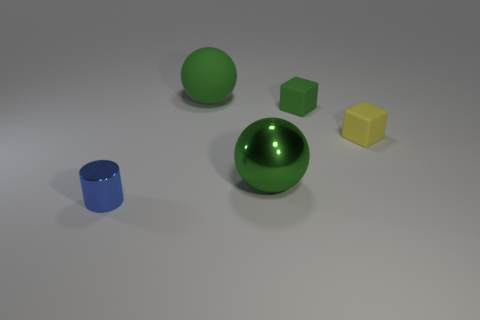There is a big ball that is right of the large green matte thing; is it the same color as the cylinder? no 